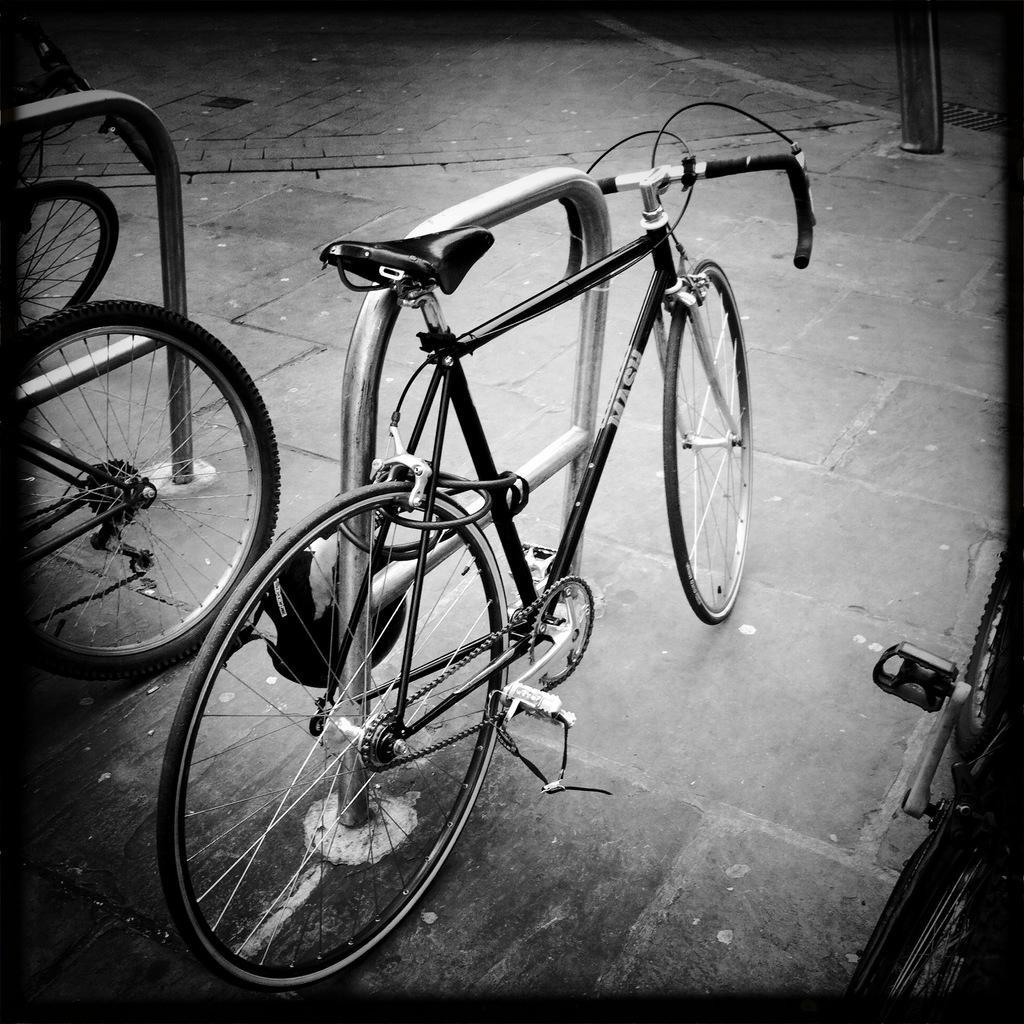How would you summarize this image in a sentence or two? In the image there is a bicycle locked to a metal stand on the side of the road, on either side of it there are few bicycles. 